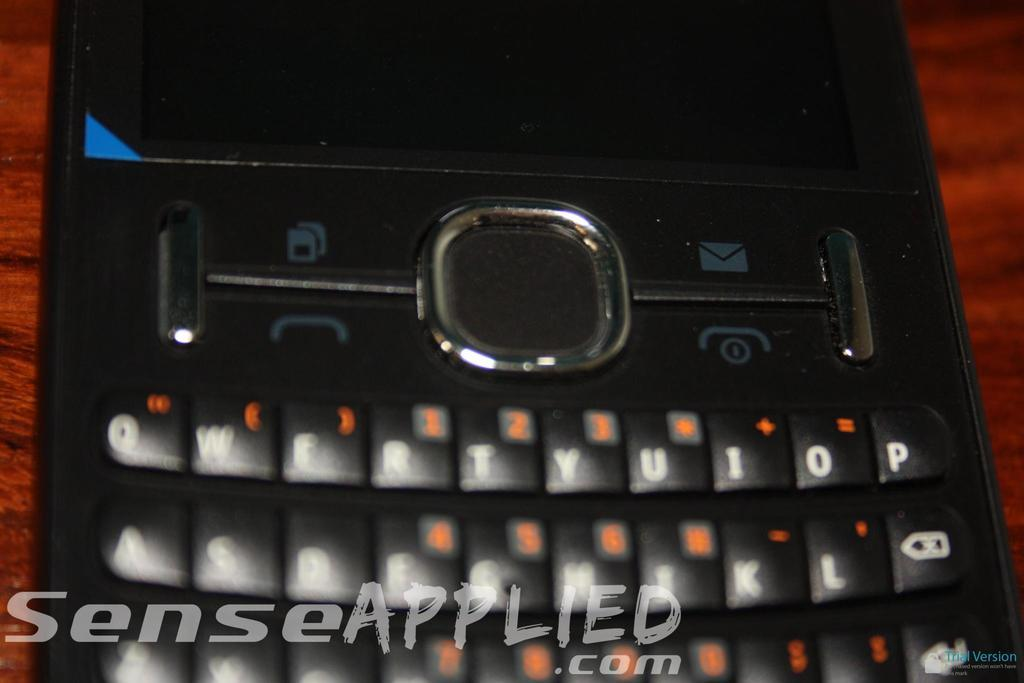<image>
Create a compact narrative representing the image presented. senseapplied.com has put their watermark on the cell phone image 